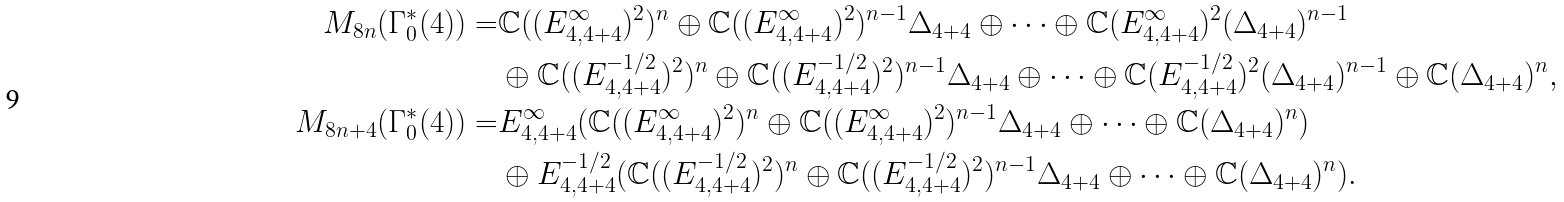Convert formula to latex. <formula><loc_0><loc_0><loc_500><loc_500>M _ { 8 n } ( \Gamma _ { 0 } ^ { * } ( 4 ) ) = & \mathbb { C } ( ( E _ { 4 , 4 + 4 } ^ { \infty } ) ^ { 2 } ) ^ { n } \oplus \mathbb { C } ( ( E _ { 4 , 4 + 4 } ^ { \infty } ) ^ { 2 } ) ^ { n - 1 } \Delta _ { 4 + 4 } \oplus \cdots \oplus \mathbb { C } ( E _ { 4 , 4 + 4 } ^ { \infty } ) ^ { 2 } ( \Delta _ { 4 + 4 } ) ^ { n - 1 } \\ & \oplus \mathbb { C } ( ( E _ { 4 , 4 + 4 } ^ { - 1 / 2 } ) ^ { 2 } ) ^ { n } \oplus \mathbb { C } ( ( E _ { 4 , 4 + 4 } ^ { - 1 / 2 } ) ^ { 2 } ) ^ { n - 1 } \Delta _ { 4 + 4 } \oplus \cdots \oplus \mathbb { C } ( E _ { 4 , 4 + 4 } ^ { - 1 / 2 } ) ^ { 2 } ( \Delta _ { 4 + 4 } ) ^ { n - 1 } \oplus \mathbb { C } ( \Delta _ { 4 + 4 } ) ^ { n } , \\ M _ { 8 n + 4 } ( \Gamma _ { 0 } ^ { * } ( 4 ) ) = & E _ { 4 , 4 + 4 } ^ { \infty } ( \mathbb { C } ( ( E _ { 4 , 4 + 4 } ^ { \infty } ) ^ { 2 } ) ^ { n } \oplus \mathbb { C } ( ( E _ { 4 , 4 + 4 } ^ { \infty } ) ^ { 2 } ) ^ { n - 1 } \Delta _ { 4 + 4 } \oplus \cdots \oplus \mathbb { C } ( \Delta _ { 4 + 4 } ) ^ { n } ) \\ & \oplus E _ { 4 , 4 + 4 } ^ { - 1 / 2 } ( \mathbb { C } ( ( E _ { 4 , 4 + 4 } ^ { - 1 / 2 } ) ^ { 2 } ) ^ { n } \oplus \mathbb { C } ( ( E _ { 4 , 4 + 4 } ^ { - 1 / 2 } ) ^ { 2 } ) ^ { n - 1 } \Delta _ { 4 + 4 } \oplus \cdots \oplus \mathbb { C } ( \Delta _ { 4 + 4 } ) ^ { n } ) .</formula> 